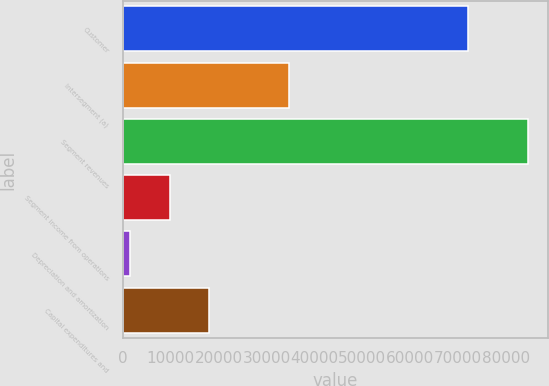<chart> <loc_0><loc_0><loc_500><loc_500><bar_chart><fcel>Customer<fcel>Intersegment (a)<fcel>Segment revenues<fcel>Segment income from operations<fcel>Depreciation and amortization<fcel>Capital expenditures and<nl><fcel>72051<fcel>34724.4<fcel>84636<fcel>9768.6<fcel>1450<fcel>18087.2<nl></chart> 